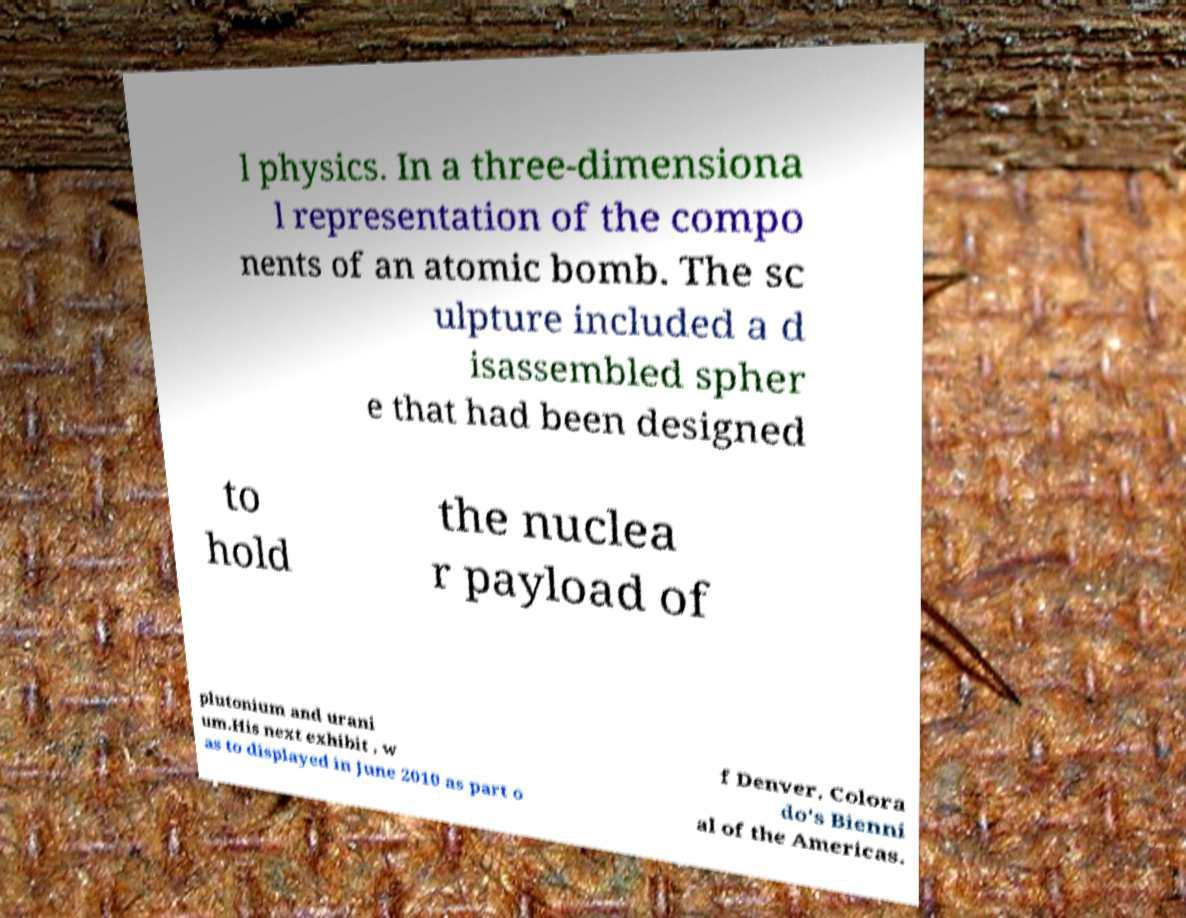I need the written content from this picture converted into text. Can you do that? l physics. In a three-dimensiona l representation of the compo nents of an atomic bomb. The sc ulpture included a d isassembled spher e that had been designed to hold the nuclea r payload of plutonium and urani um.His next exhibit , w as to displayed in June 2010 as part o f Denver, Colora do's Bienni al of the Americas. 